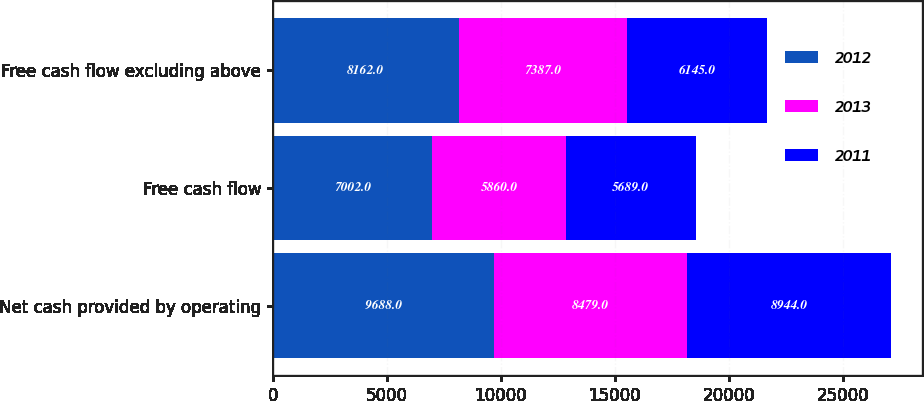Convert chart. <chart><loc_0><loc_0><loc_500><loc_500><stacked_bar_chart><ecel><fcel>Net cash provided by operating<fcel>Free cash flow<fcel>Free cash flow excluding above<nl><fcel>2012<fcel>9688<fcel>7002<fcel>8162<nl><fcel>2013<fcel>8479<fcel>5860<fcel>7387<nl><fcel>2011<fcel>8944<fcel>5689<fcel>6145<nl></chart> 